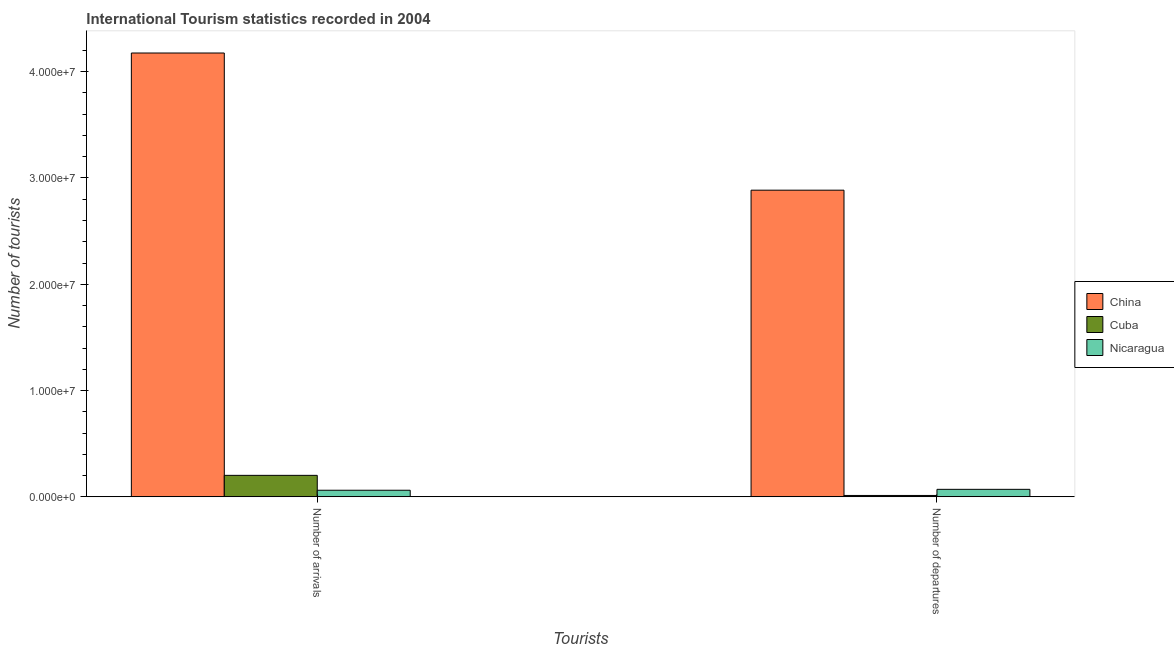How many different coloured bars are there?
Give a very brief answer. 3. How many groups of bars are there?
Make the answer very short. 2. Are the number of bars per tick equal to the number of legend labels?
Keep it short and to the point. Yes. How many bars are there on the 1st tick from the right?
Provide a short and direct response. 3. What is the label of the 1st group of bars from the left?
Ensure brevity in your answer.  Number of arrivals. What is the number of tourist arrivals in Cuba?
Your response must be concise. 2.02e+06. Across all countries, what is the maximum number of tourist arrivals?
Offer a terse response. 4.18e+07. Across all countries, what is the minimum number of tourist arrivals?
Offer a very short reply. 6.15e+05. In which country was the number of tourist departures minimum?
Offer a terse response. Cuba. What is the total number of tourist arrivals in the graph?
Give a very brief answer. 4.44e+07. What is the difference between the number of tourist arrivals in Nicaragua and that in Cuba?
Give a very brief answer. -1.40e+06. What is the difference between the number of tourist arrivals in Cuba and the number of tourist departures in China?
Provide a short and direct response. -2.68e+07. What is the average number of tourist departures per country?
Your answer should be compact. 9.89e+06. What is the difference between the number of tourist departures and number of tourist arrivals in Nicaragua?
Provide a succinct answer. 8.60e+04. In how many countries, is the number of tourist departures greater than 38000000 ?
Offer a very short reply. 0. What is the ratio of the number of tourist arrivals in China to that in Cuba?
Keep it short and to the point. 20.7. Is the number of tourist arrivals in China less than that in Nicaragua?
Provide a short and direct response. No. What does the 2nd bar from the left in Number of departures represents?
Make the answer very short. Cuba. What does the 2nd bar from the right in Number of departures represents?
Keep it short and to the point. Cuba. Are all the bars in the graph horizontal?
Your response must be concise. No. Are the values on the major ticks of Y-axis written in scientific E-notation?
Your answer should be compact. Yes. Does the graph contain grids?
Your answer should be very brief. No. Where does the legend appear in the graph?
Your answer should be compact. Center right. What is the title of the graph?
Offer a very short reply. International Tourism statistics recorded in 2004. Does "Sao Tome and Principe" appear as one of the legend labels in the graph?
Make the answer very short. No. What is the label or title of the X-axis?
Provide a short and direct response. Tourists. What is the label or title of the Y-axis?
Provide a short and direct response. Number of tourists. What is the Number of tourists in China in Number of arrivals?
Ensure brevity in your answer.  4.18e+07. What is the Number of tourists of Cuba in Number of arrivals?
Offer a terse response. 2.02e+06. What is the Number of tourists in Nicaragua in Number of arrivals?
Keep it short and to the point. 6.15e+05. What is the Number of tourists of China in Number of departures?
Provide a succinct answer. 2.89e+07. What is the Number of tourists in Cuba in Number of departures?
Your answer should be very brief. 1.24e+05. What is the Number of tourists in Nicaragua in Number of departures?
Keep it short and to the point. 7.01e+05. Across all Tourists, what is the maximum Number of tourists in China?
Keep it short and to the point. 4.18e+07. Across all Tourists, what is the maximum Number of tourists of Cuba?
Your response must be concise. 2.02e+06. Across all Tourists, what is the maximum Number of tourists of Nicaragua?
Offer a very short reply. 7.01e+05. Across all Tourists, what is the minimum Number of tourists in China?
Provide a succinct answer. 2.89e+07. Across all Tourists, what is the minimum Number of tourists of Cuba?
Make the answer very short. 1.24e+05. Across all Tourists, what is the minimum Number of tourists of Nicaragua?
Offer a very short reply. 6.15e+05. What is the total Number of tourists in China in the graph?
Provide a succinct answer. 7.06e+07. What is the total Number of tourists in Cuba in the graph?
Your answer should be compact. 2.14e+06. What is the total Number of tourists in Nicaragua in the graph?
Offer a very short reply. 1.32e+06. What is the difference between the Number of tourists in China in Number of arrivals and that in Number of departures?
Offer a very short reply. 1.29e+07. What is the difference between the Number of tourists in Cuba in Number of arrivals and that in Number of departures?
Keep it short and to the point. 1.89e+06. What is the difference between the Number of tourists of Nicaragua in Number of arrivals and that in Number of departures?
Make the answer very short. -8.60e+04. What is the difference between the Number of tourists of China in Number of arrivals and the Number of tourists of Cuba in Number of departures?
Your answer should be compact. 4.16e+07. What is the difference between the Number of tourists of China in Number of arrivals and the Number of tourists of Nicaragua in Number of departures?
Keep it short and to the point. 4.11e+07. What is the difference between the Number of tourists of Cuba in Number of arrivals and the Number of tourists of Nicaragua in Number of departures?
Your answer should be very brief. 1.32e+06. What is the average Number of tourists in China per Tourists?
Provide a short and direct response. 3.53e+07. What is the average Number of tourists in Cuba per Tourists?
Provide a short and direct response. 1.07e+06. What is the average Number of tourists in Nicaragua per Tourists?
Keep it short and to the point. 6.58e+05. What is the difference between the Number of tourists of China and Number of tourists of Cuba in Number of arrivals?
Provide a succinct answer. 3.97e+07. What is the difference between the Number of tourists in China and Number of tourists in Nicaragua in Number of arrivals?
Keep it short and to the point. 4.11e+07. What is the difference between the Number of tourists in Cuba and Number of tourists in Nicaragua in Number of arrivals?
Make the answer very short. 1.40e+06. What is the difference between the Number of tourists of China and Number of tourists of Cuba in Number of departures?
Provide a succinct answer. 2.87e+07. What is the difference between the Number of tourists in China and Number of tourists in Nicaragua in Number of departures?
Keep it short and to the point. 2.82e+07. What is the difference between the Number of tourists of Cuba and Number of tourists of Nicaragua in Number of departures?
Offer a terse response. -5.77e+05. What is the ratio of the Number of tourists in China in Number of arrivals to that in Number of departures?
Keep it short and to the point. 1.45. What is the ratio of the Number of tourists of Cuba in Number of arrivals to that in Number of departures?
Provide a succinct answer. 16.27. What is the ratio of the Number of tourists of Nicaragua in Number of arrivals to that in Number of departures?
Provide a succinct answer. 0.88. What is the difference between the highest and the second highest Number of tourists in China?
Your answer should be compact. 1.29e+07. What is the difference between the highest and the second highest Number of tourists of Cuba?
Your answer should be very brief. 1.89e+06. What is the difference between the highest and the second highest Number of tourists in Nicaragua?
Your answer should be very brief. 8.60e+04. What is the difference between the highest and the lowest Number of tourists of China?
Your answer should be very brief. 1.29e+07. What is the difference between the highest and the lowest Number of tourists in Cuba?
Your answer should be compact. 1.89e+06. What is the difference between the highest and the lowest Number of tourists in Nicaragua?
Your response must be concise. 8.60e+04. 